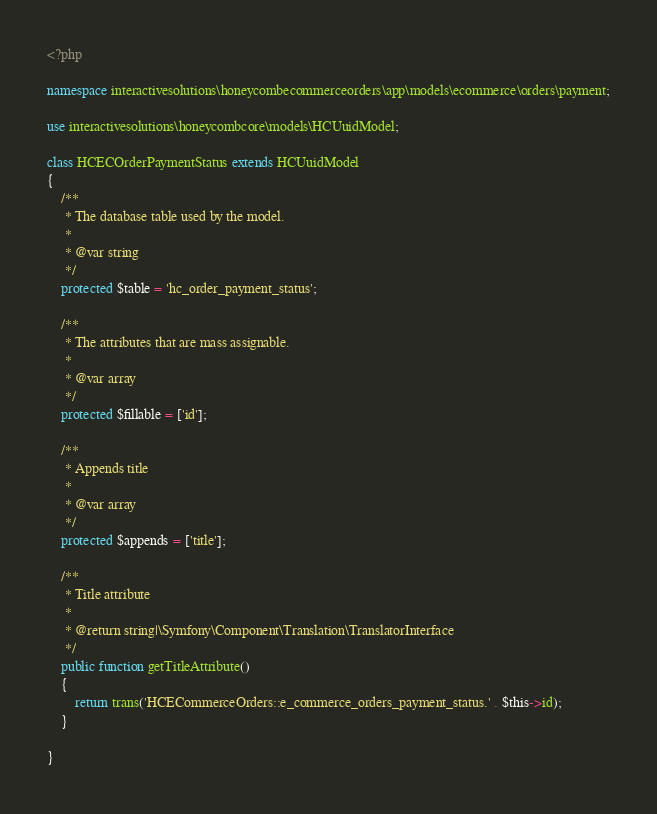Convert code to text. <code><loc_0><loc_0><loc_500><loc_500><_PHP_><?php

namespace interactivesolutions\honeycombecommerceorders\app\models\ecommerce\orders\payment;

use interactivesolutions\honeycombcore\models\HCUuidModel;

class HCECOrderPaymentStatus extends HCUuidModel
{
    /**
     * The database table used by the model.
     *
     * @var string
     */
    protected $table = 'hc_order_payment_status';

    /**
     * The attributes that are mass assignable.
     *
     * @var array
     */
    protected $fillable = ['id'];

    /**
     * Appends title
     *
     * @var array
     */
    protected $appends = ['title'];

    /**
     * Title attribute
     *
     * @return string|\Symfony\Component\Translation\TranslatorInterface
     */
    public function getTitleAttribute()
    {
        return trans('HCECommerceOrders::e_commerce_orders_payment_status.' . $this->id);
    }

}</code> 